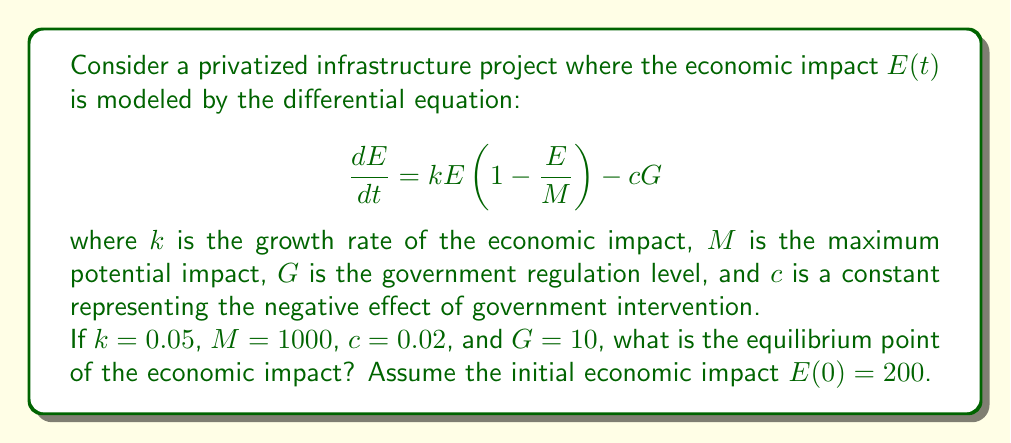Give your solution to this math problem. To find the equilibrium point, we need to set $\frac{dE}{dt} = 0$ and solve for $E$:

$$0 = kE(1 - \frac{E}{M}) - cG$$

Substituting the given values:

$$0 = 0.05E(1 - \frac{E}{1000}) - 0.02(10)$$

Simplifying:

$$0 = 0.05E - 0.00005E^2 - 0.2$$

Multiplying both sides by 20000:

$$0 = 1000E - E^2 - 4000$$

This is a quadratic equation. Let's rearrange it to standard form:

$$E^2 - 1000E + 4000 = 0$$

Now we can use the quadratic formula to solve for $E$:

$$E = \frac{-b \pm \sqrt{b^2 - 4ac}}{2a}$$

Where $a = 1$, $b = -1000$, and $c = 4000$

$$E = \frac{1000 \pm \sqrt{1000000 - 16000}}{2}$$

$$E = \frac{1000 \pm \sqrt{984000}}{2}$$

$$E = \frac{1000 \pm 992}{2}$$

This gives us two solutions:

$$E_1 = \frac{1000 + 992}{2} = 996$$
$$E_2 = \frac{1000 - 992}{2} = 4$$

The larger value, 996, represents the stable equilibrium point, while 4 is an unstable equilibrium. Since the initial economic impact $E(0) = 200$ is greater than the unstable equilibrium, the system will tend towards the stable equilibrium of 996.
Answer: The stable equilibrium point of the economic impact is 996. 